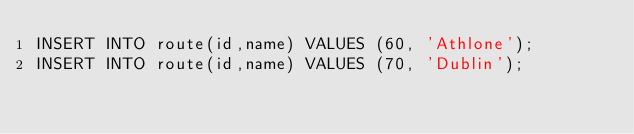Convert code to text. <code><loc_0><loc_0><loc_500><loc_500><_SQL_>INSERT INTO route(id,name) VALUES (60, 'Athlone');
INSERT INTO route(id,name) VALUES (70, 'Dublin');
</code> 